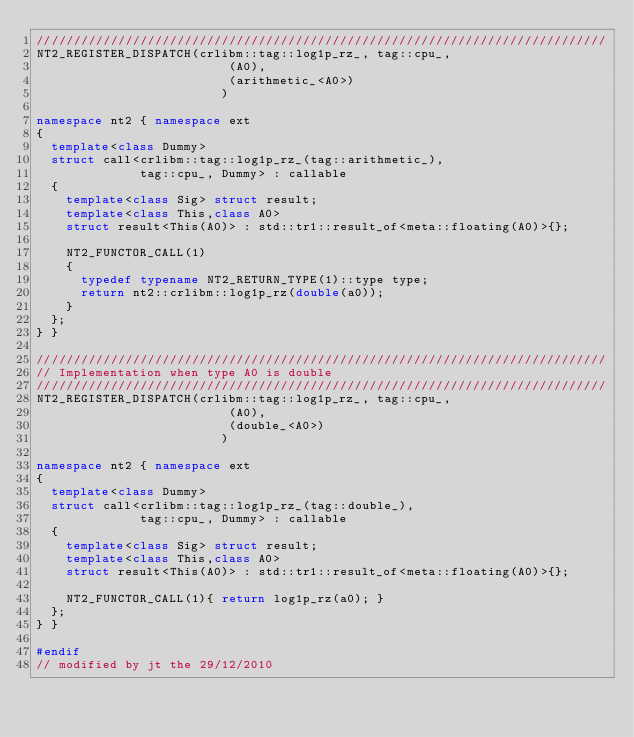<code> <loc_0><loc_0><loc_500><loc_500><_C++_>/////////////////////////////////////////////////////////////////////////////
NT2_REGISTER_DISPATCH(crlibm::tag::log1p_rz_, tag::cpu_,
                          (A0),
                          (arithmetic_<A0>)
                         )

namespace nt2 { namespace ext
{
  template<class Dummy>
  struct call<crlibm::tag::log1p_rz_(tag::arithmetic_),
              tag::cpu_, Dummy> : callable
  {
    template<class Sig> struct result;
    template<class This,class A0>
    struct result<This(A0)> : std::tr1::result_of<meta::floating(A0)>{};

    NT2_FUNCTOR_CALL(1)
    {
      typedef typename NT2_RETURN_TYPE(1)::type type;
      return nt2::crlibm::log1p_rz(double(a0));
    }
  };
} }

/////////////////////////////////////////////////////////////////////////////
// Implementation when type A0 is double
/////////////////////////////////////////////////////////////////////////////
NT2_REGISTER_DISPATCH(crlibm::tag::log1p_rz_, tag::cpu_,
                          (A0),
                          (double_<A0>)
                         )

namespace nt2 { namespace ext
{
  template<class Dummy>
  struct call<crlibm::tag::log1p_rz_(tag::double_),
              tag::cpu_, Dummy> : callable
  {
    template<class Sig> struct result;
    template<class This,class A0>
    struct result<This(A0)> : std::tr1::result_of<meta::floating(A0)>{};

    NT2_FUNCTOR_CALL(1){ return log1p_rz(a0); }
  };
} }

#endif
// modified by jt the 29/12/2010</code> 